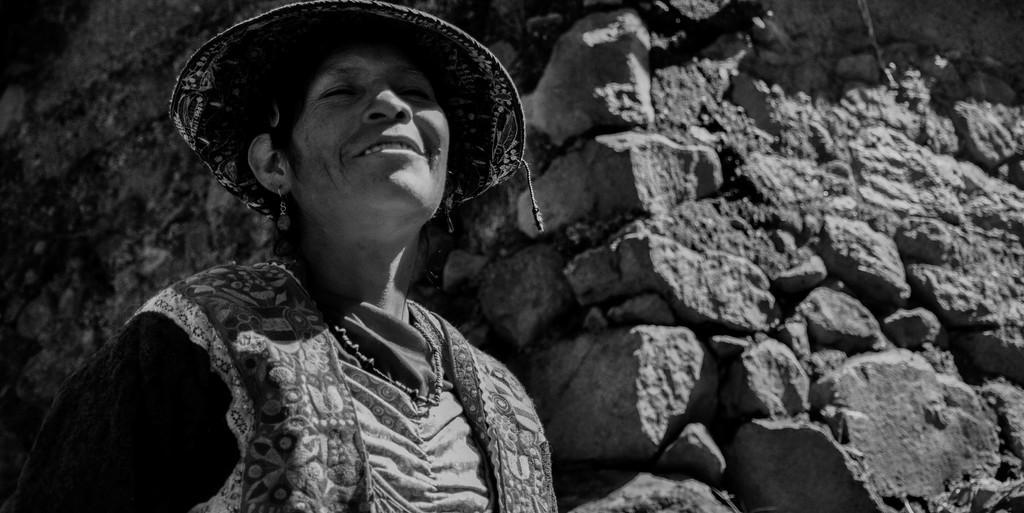In one or two sentences, can you explain what this image depicts? This is a black and white image. In this image we can see woman standing and wearing hat. In the background there is wall. 